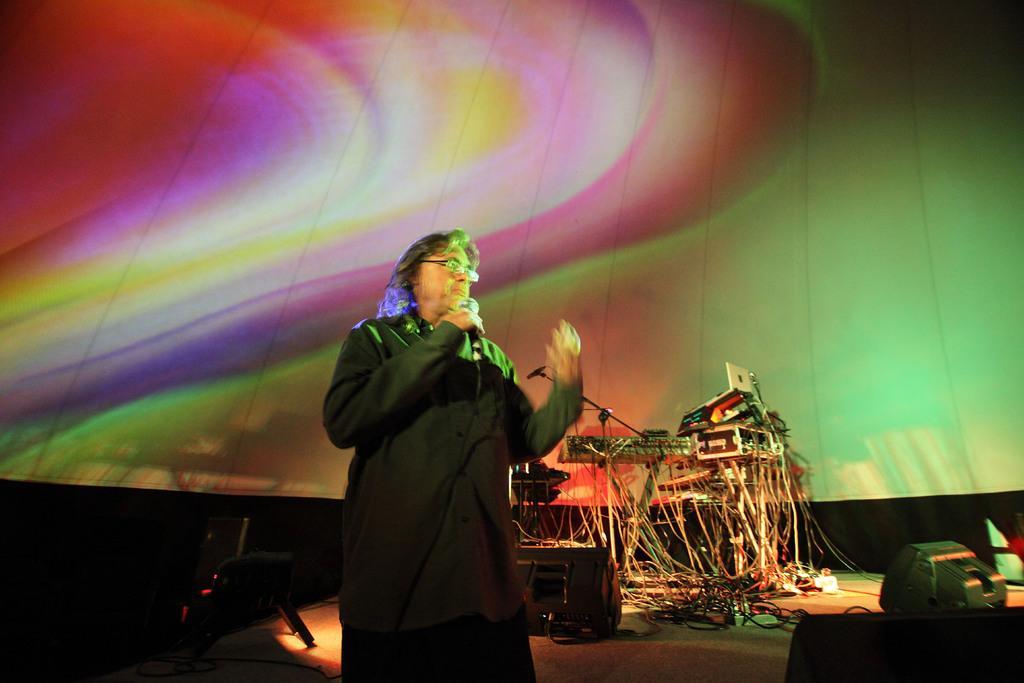How would you summarize this image in a sentence or two? In this image, we can see a musical equipment. There is a person standing in front of the screen. This person is holding a mic with his hand. There are lights at the bottom of the image. 